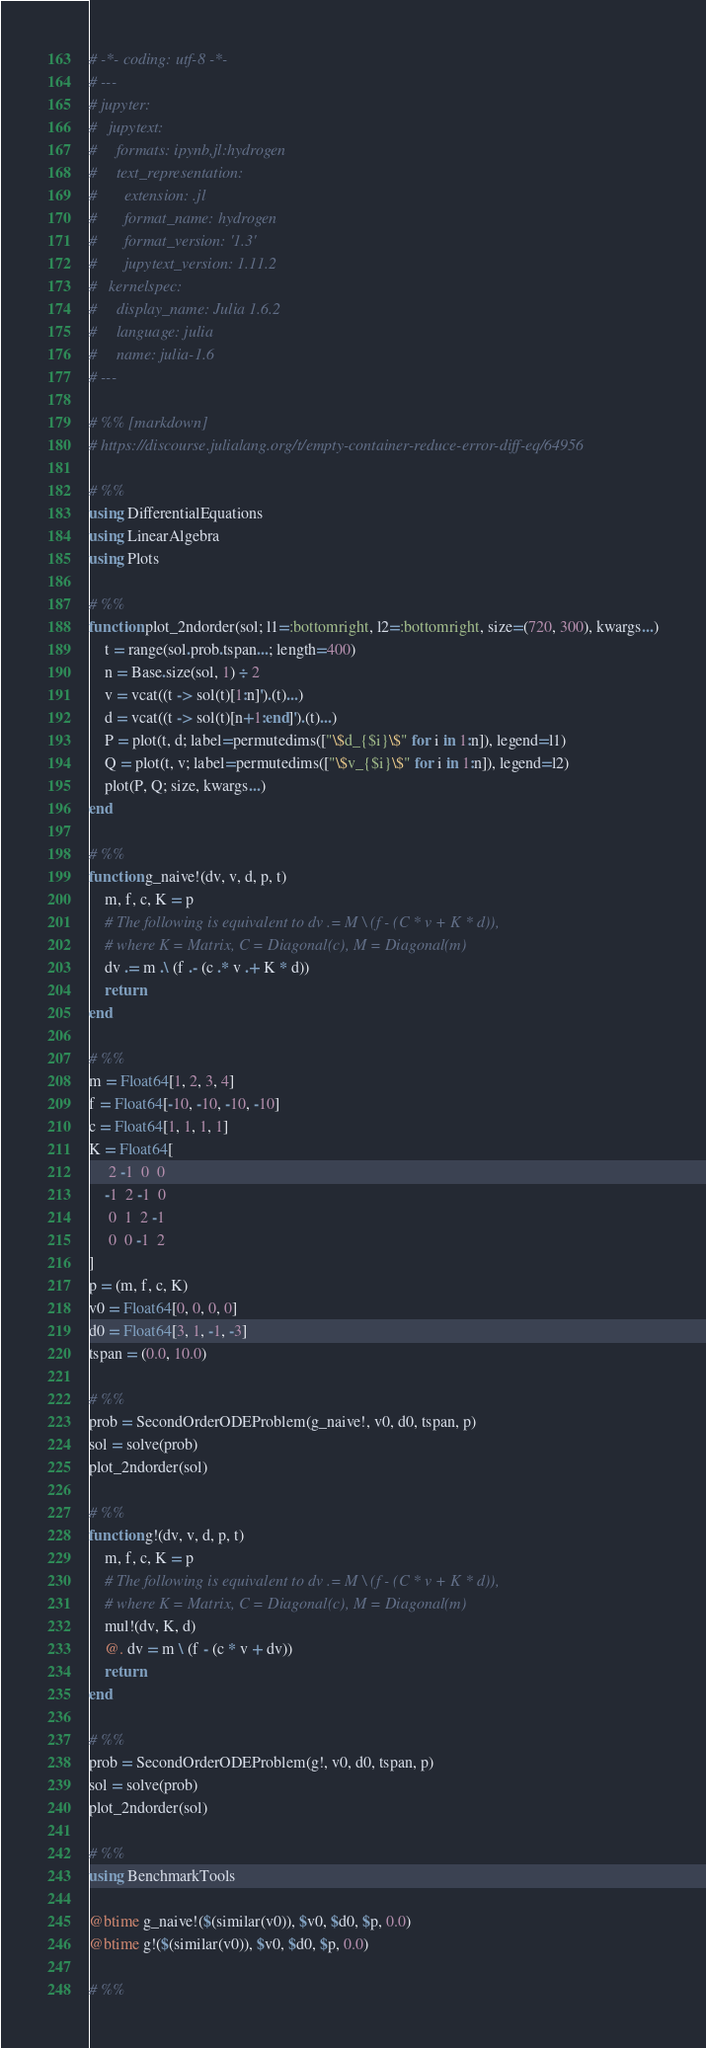<code> <loc_0><loc_0><loc_500><loc_500><_Julia_># -*- coding: utf-8 -*-
# ---
# jupyter:
#   jupytext:
#     formats: ipynb,jl:hydrogen
#     text_representation:
#       extension: .jl
#       format_name: hydrogen
#       format_version: '1.3'
#       jupytext_version: 1.11.2
#   kernelspec:
#     display_name: Julia 1.6.2
#     language: julia
#     name: julia-1.6
# ---

# %% [markdown]
# https://discourse.julialang.org/t/empty-container-reduce-error-diff-eq/64956

# %%
using DifferentialEquations
using LinearAlgebra
using Plots

# %%
function plot_2ndorder(sol; l1=:bottomright, l2=:bottomright, size=(720, 300), kwargs...)
    t = range(sol.prob.tspan...; length=400)
    n = Base.size(sol, 1) ÷ 2
    v = vcat((t -> sol(t)[1:n]').(t)...)
    d = vcat((t -> sol(t)[n+1:end]').(t)...)
    P = plot(t, d; label=permutedims(["\$d_{$i}\$" for i in 1:n]), legend=l1)
    Q = plot(t, v; label=permutedims(["\$v_{$i}\$" for i in 1:n]), legend=l2)
    plot(P, Q; size, kwargs...)
end

# %%
function g_naive!(dv, v, d, p, t)
    m, f, c, K = p
    # The following is equivalent to dv .= M \ (f - (C * v + K * d)),
    # where K = Matrix, C = Diagonal(c), M = Diagonal(m)
    dv .= m .\ (f .- (c .* v .+ K * d))
    return
end

# %%
m = Float64[1, 2, 3, 4]
f = Float64[-10, -10, -10, -10]
c = Float64[1, 1, 1, 1]
K = Float64[
     2 -1  0  0
    -1  2 -1  0
     0  1  2 -1
     0  0 -1  2
]
p = (m, f, c, K)
v0 = Float64[0, 0, 0, 0]
d0 = Float64[3, 1, -1, -3]
tspan = (0.0, 10.0)

# %%
prob = SecondOrderODEProblem(g_naive!, v0, d0, tspan, p)
sol = solve(prob)
plot_2ndorder(sol)

# %%
function g!(dv, v, d, p, t)
    m, f, c, K = p
    # The following is equivalent to dv .= M \ (f - (C * v + K * d)),
    # where K = Matrix, C = Diagonal(c), M = Diagonal(m)
    mul!(dv, K, d)
    @. dv = m \ (f - (c * v + dv))
    return
end

# %%
prob = SecondOrderODEProblem(g!, v0, d0, tspan, p)
sol = solve(prob)
plot_2ndorder(sol)

# %%
using BenchmarkTools

@btime g_naive!($(similar(v0)), $v0, $d0, $p, 0.0)
@btime g!($(similar(v0)), $v0, $d0, $p, 0.0)

# %%
</code> 